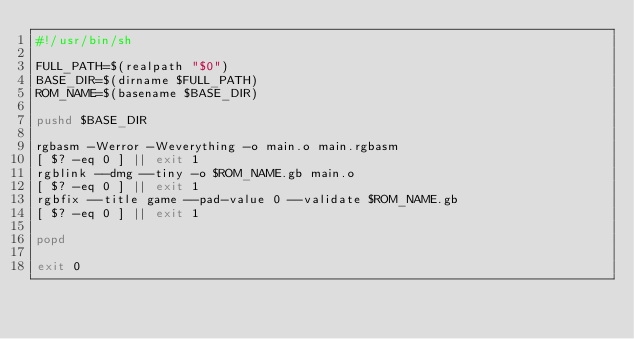Convert code to text. <code><loc_0><loc_0><loc_500><loc_500><_Bash_>#!/usr/bin/sh

FULL_PATH=$(realpath "$0")
BASE_DIR=$(dirname $FULL_PATH)
ROM_NAME=$(basename $BASE_DIR)

pushd $BASE_DIR

rgbasm -Werror -Weverything -o main.o main.rgbasm
[ $? -eq 0 ] || exit 1
rgblink --dmg --tiny -o $ROM_NAME.gb main.o
[ $? -eq 0 ] || exit 1
rgbfix --title game --pad-value 0 --validate $ROM_NAME.gb
[ $? -eq 0 ] || exit 1

popd

exit 0

</code> 